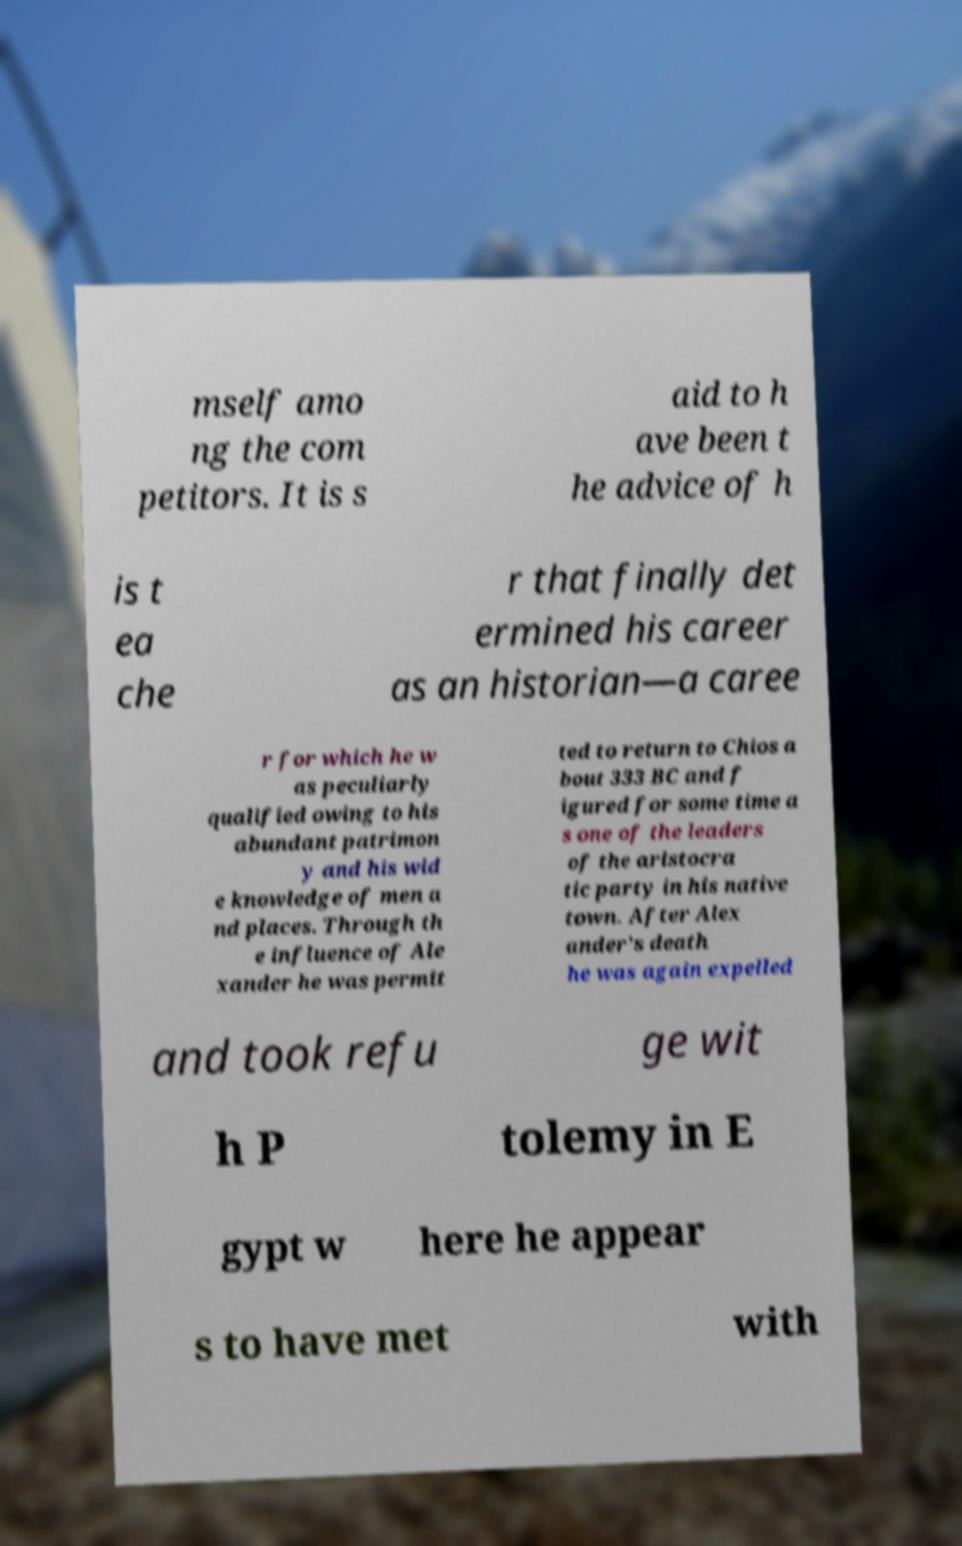I need the written content from this picture converted into text. Can you do that? mself amo ng the com petitors. It is s aid to h ave been t he advice of h is t ea che r that finally det ermined his career as an historian—a caree r for which he w as peculiarly qualified owing to his abundant patrimon y and his wid e knowledge of men a nd places. Through th e influence of Ale xander he was permit ted to return to Chios a bout 333 BC and f igured for some time a s one of the leaders of the aristocra tic party in his native town. After Alex ander's death he was again expelled and took refu ge wit h P tolemy in E gypt w here he appear s to have met with 